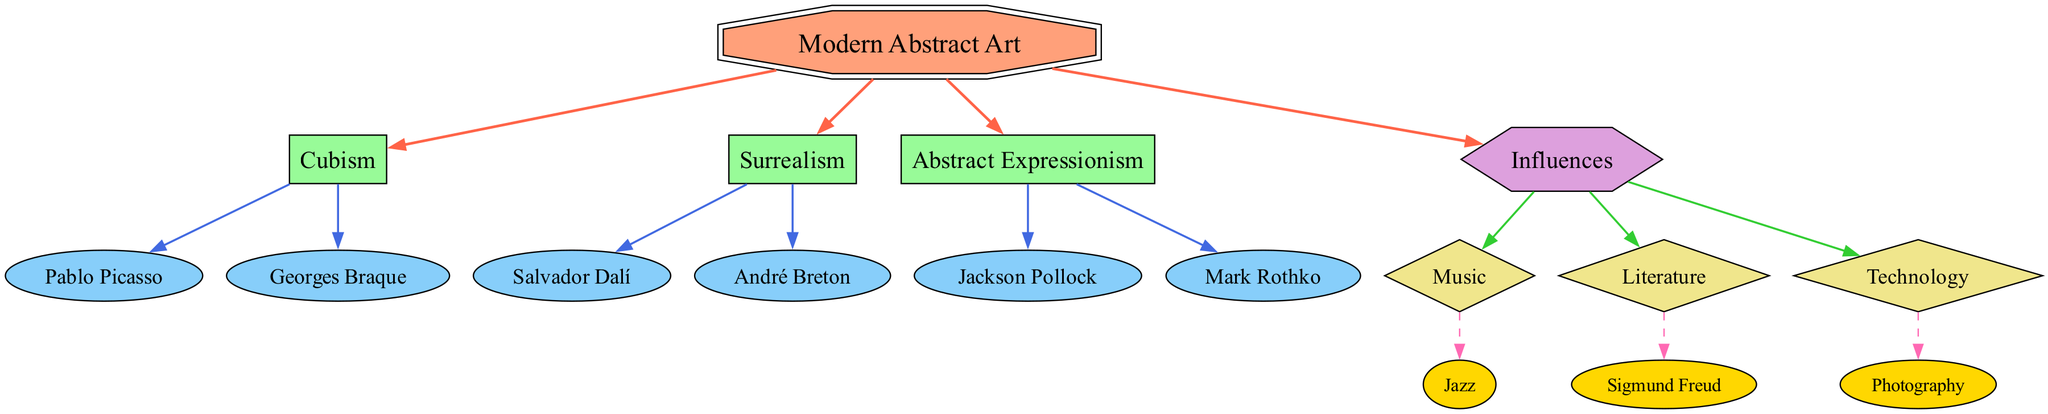What is the main topic of the diagram? The main topic can be identified by looking for the node labeled with 'main_topic.' In this case, the node labeled "Modern Abstract Art" fits this description, as it is central to the diagram.
Answer: Modern Abstract Art How many artistic movements are related to modern abstract art? By counting the nodes connected to the main topic labeled 'related_to,' we find three artistic movements: Cubism, Surrealism, and Abstract Expressionism.
Answer: 3 Who are the key artists of Cubism? To answer this, we identify the nodes linked to the Cubism node via 'key_artist' edges. The artists connected are Pablo Picasso and Georges Braque.
Answer: Pablo Picasso, Georges Braque Which influence is exemplified by Sigmund Freud? We look for the influence node that includes this specific influence, and by tracing the edges, we see Sigmund Freud connected to the Literature influence node.
Answer: Literature What is a specific influence associated with Technology? Here, we trace from the Technology influence node down to its example, which is Photography. The relationship indicates that Photography provides a specific reference for the influence of Technology in this context.
Answer: Photography Which artistic movement has Jackson Pollock as a key artist? To find this, we examine the edges from the main topic Modern Abstract Art to Artistic Movements and further look under Abstract Expressionism. We find that Jackson Pollock is directly connected as a key artist for Abstract Expressionism.
Answer: Abstract Expressionism How many specific influences are mentioned in this diagram? We count the specific influences by looking at the nodes classified under 'specific_influence.' The diagram mentions Jazz and Photography as specific influences under the broader influence categories. This gives a total of two specific influences.
Answer: 2 What type of relationship connects "Modern Abstract Art" to "Influences"? The relationship type between these two nodes can be found by following the edges from the main topic to the influences node. In this case, the relationship is 'related_to,' suggesting a general connection to the broader concept of influences.
Answer: related_to Which artistic movement is associated with Salvador Dalí? To determine this, we look for Salvador Dalí's node and then trace its connection back to the artistic movement node. Dalí is connected to Surrealism, thus identifying the artistic movement he represents.
Answer: Surrealism 